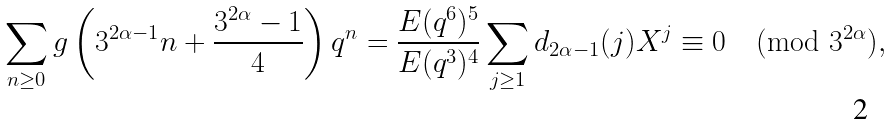<formula> <loc_0><loc_0><loc_500><loc_500>\sum _ { n \geq 0 } g \left ( 3 ^ { 2 \alpha - 1 } n + \frac { 3 ^ { 2 \alpha } - 1 } { 4 } \right ) q ^ { n } & = \frac { E ( q ^ { 6 } ) ^ { 5 } } { E ( q ^ { 3 } ) ^ { 4 } } \sum _ { j \geq 1 } d _ { 2 \alpha - 1 } ( j ) X ^ { j } \equiv 0 \pmod { 3 ^ { 2 \alpha } } ,</formula> 